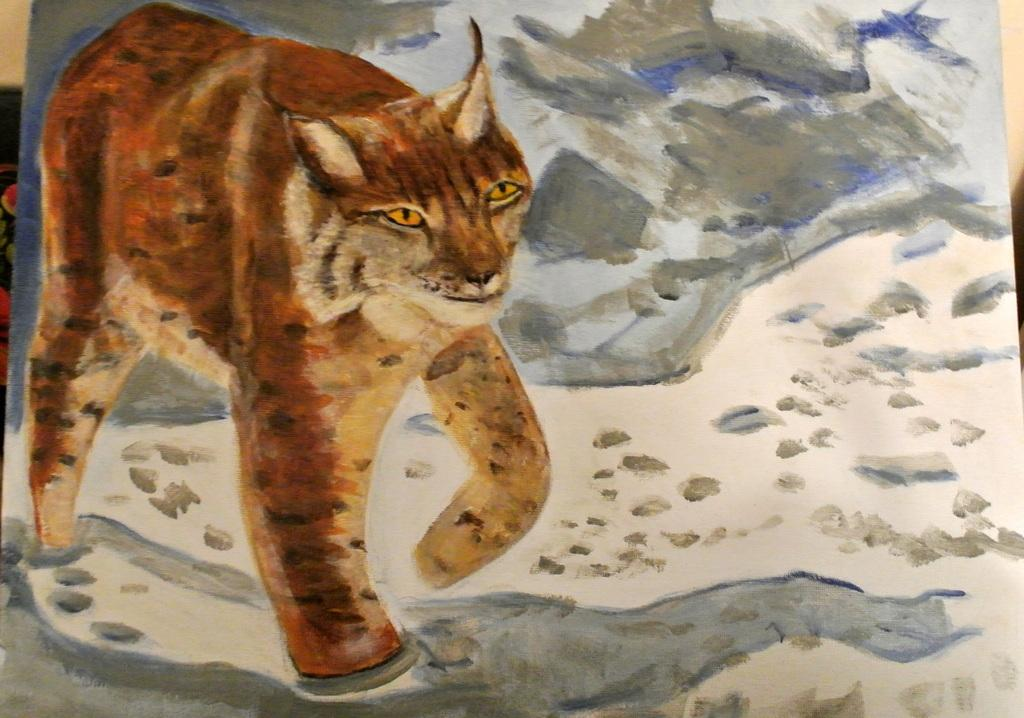What is the main subject of the painted paper in the image? The painted paper features a tiger. Are there any other elements present in the painted paper? Yes, the painted paper also features water. What can be seen in the background of the image? There is a wall in the background of the image. How often does the tiger dust the stick in the image? There is no tiger dusting a stick in the image, as the tiger is a painted subject and not a real animal. 